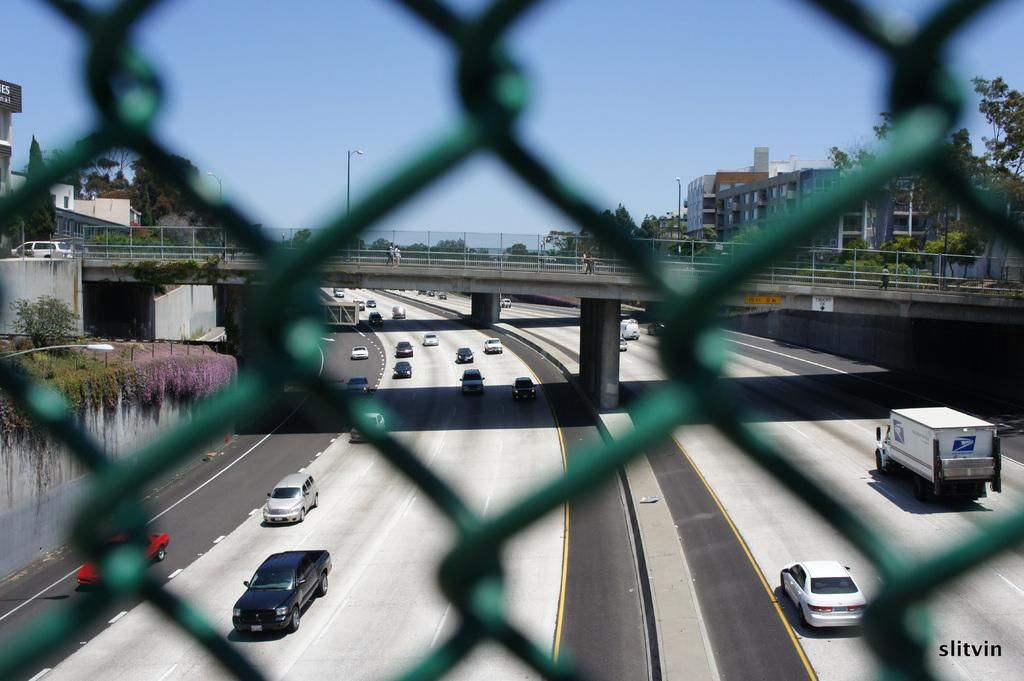What is located in the foreground of the image? There is a net in the foreground of the image. What type of structures can be seen in the image? There are buildings in the image. What type of vehicles are present in the image? There are cars in the image. What type of vertical structures can be seen in the image? There are poles in the image. What type of vegetation is present in the image? There are trees in the image. What type of man-made structure can be seen spanning a body of water in the image? There is a bridge in the image. How many dogs are running on the bridge in the image? There are no dogs present in the image, and therefore no dogs are running on the bridge. 